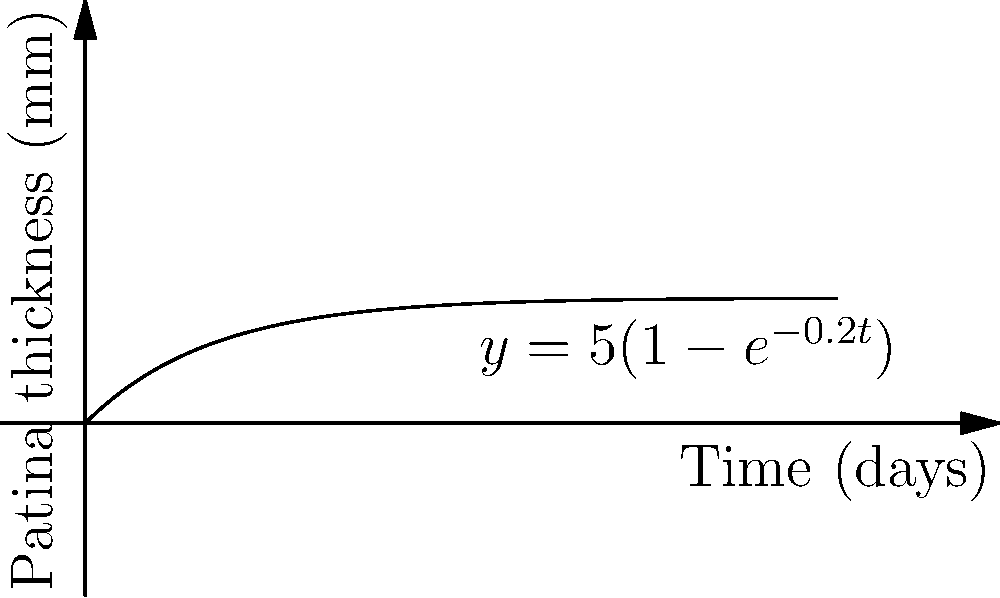A bronze sculpture begins to develop a patina over time. The thickness of the patina, $y$ (in mm), after $t$ days is modeled by the function $y = 5(1-e^{-0.2t})$. At what rate (in mm/day) is the patina thickness increasing after 10 days? To find the rate of change of patina thickness after 10 days, we need to follow these steps:

1) The rate of change is given by the derivative of the function. Let's find $\frac{dy}{dt}$:

   $\frac{d}{dt}[5(1-e^{-0.2t})] = 5 \cdot \frac{d}{dt}[1-e^{-0.2t}] = 5 \cdot 0.2e^{-0.2t} = e^{-0.2t}$

2) Now that we have the derivative, we need to evaluate it at $t=10$:

   $\frac{dy}{dt}|_{t=10} = e^{-0.2(10)} = e^{-2}$

3) We can calculate this value:

   $e^{-2} \approx 0.1353$ mm/day

Therefore, after 10 days, the patina thickness is increasing at a rate of approximately 0.1353 mm/day.
Answer: $e^{-2}$ mm/day or approximately 0.1353 mm/day 